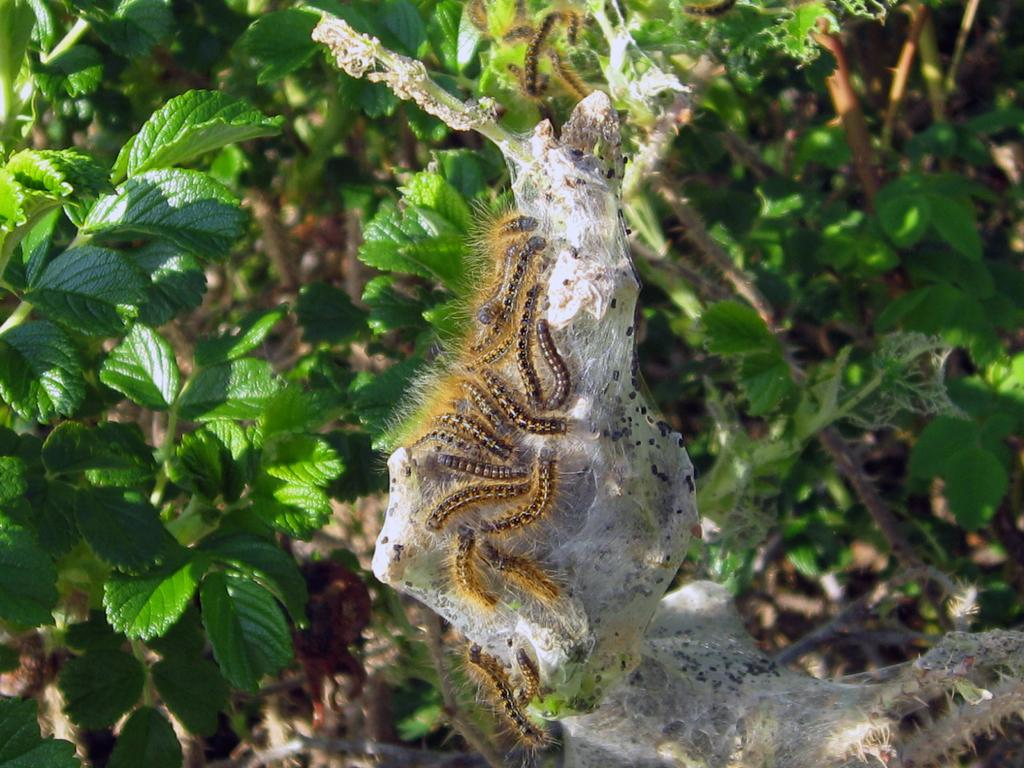What type of creatures can be seen in the image? There are insects in the image. Where are the insects located? The insects are on a white object. What can be seen in the background of the image? There are plants in the background of the image. What type of pump can be seen in the image? There is no pump present in the image. What type of lettuce is being used as a toy in the image? There is no lettuce or toy present in the image. 